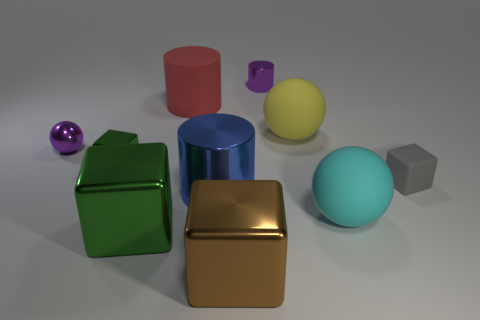Subtract all metallic blocks. How many blocks are left? 1 Subtract 1 balls. How many balls are left? 2 Subtract all cyan cubes. Subtract all purple cylinders. How many cubes are left? 4 Subtract all green objects. Subtract all red cylinders. How many objects are left? 7 Add 6 brown things. How many brown things are left? 7 Add 4 large yellow matte spheres. How many large yellow matte spheres exist? 5 Subtract 0 cyan cubes. How many objects are left? 10 Subtract all cylinders. How many objects are left? 7 